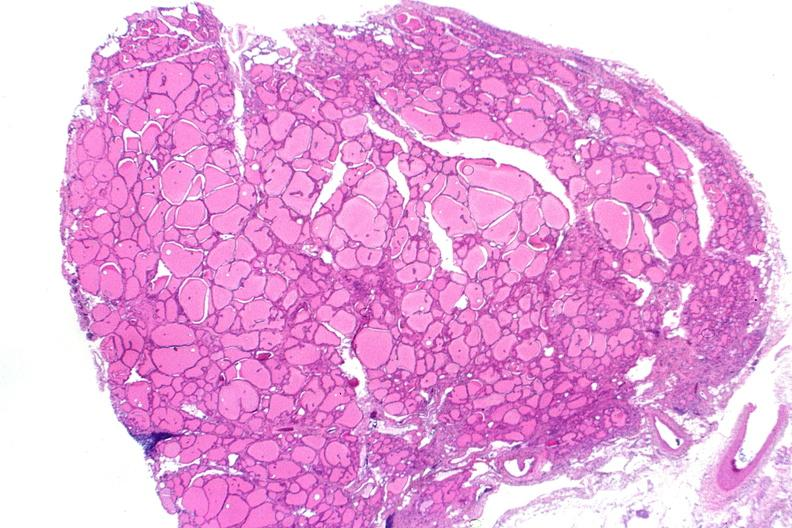s endocrine present?
Answer the question using a single word or phrase. Yes 